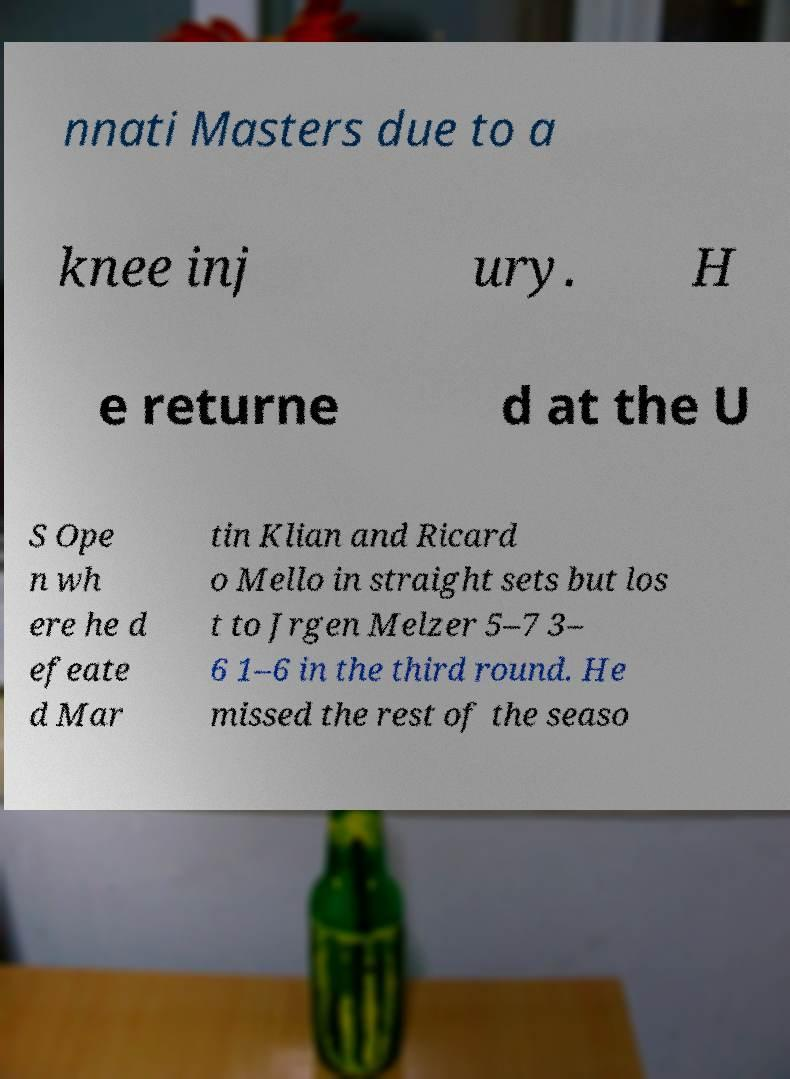Please read and relay the text visible in this image. What does it say? nnati Masters due to a knee inj ury. H e returne d at the U S Ope n wh ere he d efeate d Mar tin Klian and Ricard o Mello in straight sets but los t to Jrgen Melzer 5–7 3– 6 1–6 in the third round. He missed the rest of the seaso 